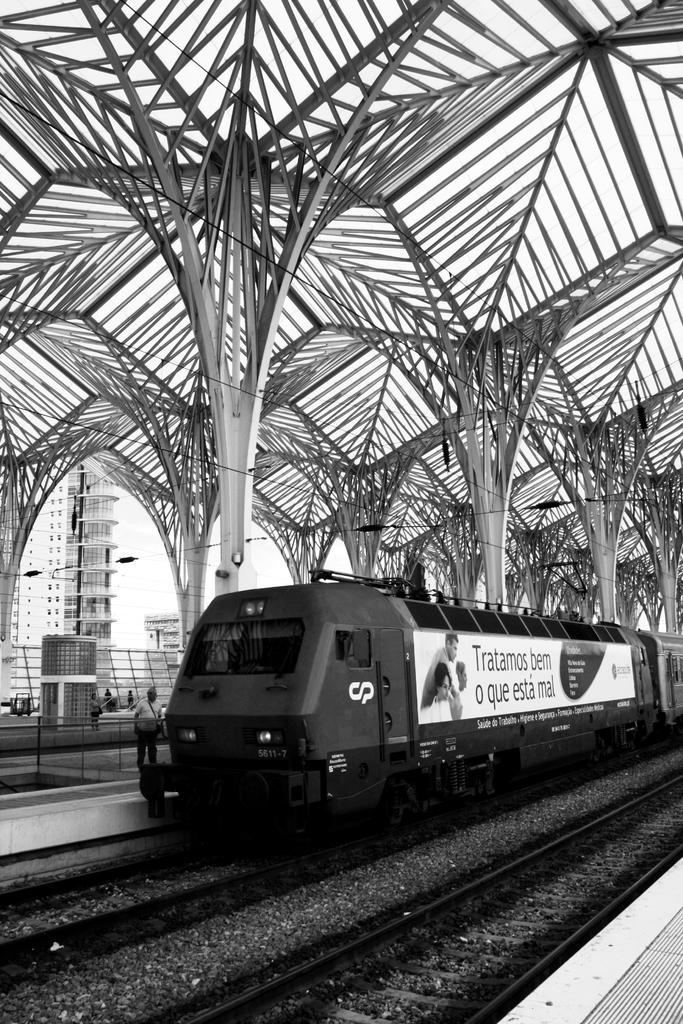What is the main subject of the image? The main subject of the image is a train on the track. What are the people near the train doing? People are standing near the train. What can be seen in the background of the image? There are buildings visible in the image. Can you describe the iron fencing in the image? There is iron fencing in the shape of a tree in the image. What type of party is being held near the train in the image? There is no party present in the image; it features a train on the track with people standing nearby. Can you tell me how many cannons are visible in the image? There are no cannons present in the image. 